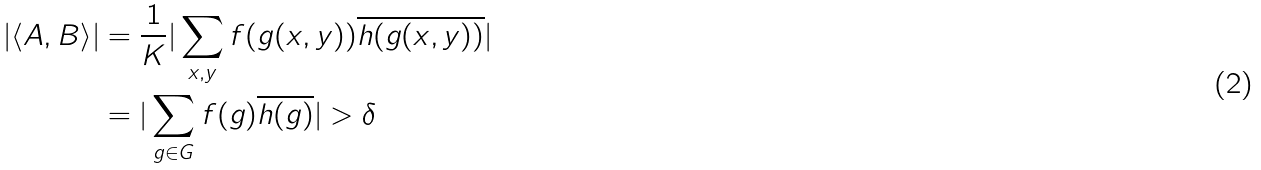Convert formula to latex. <formula><loc_0><loc_0><loc_500><loc_500>| \langle A , B \rangle | & = \frac { 1 } { K } | \sum _ { x , y } f ( g ( x , y ) ) \overline { h ( g ( x , y ) ) } | \\ & = | \sum _ { g \in G } f ( g ) \overline { h ( g ) } | > \delta</formula> 